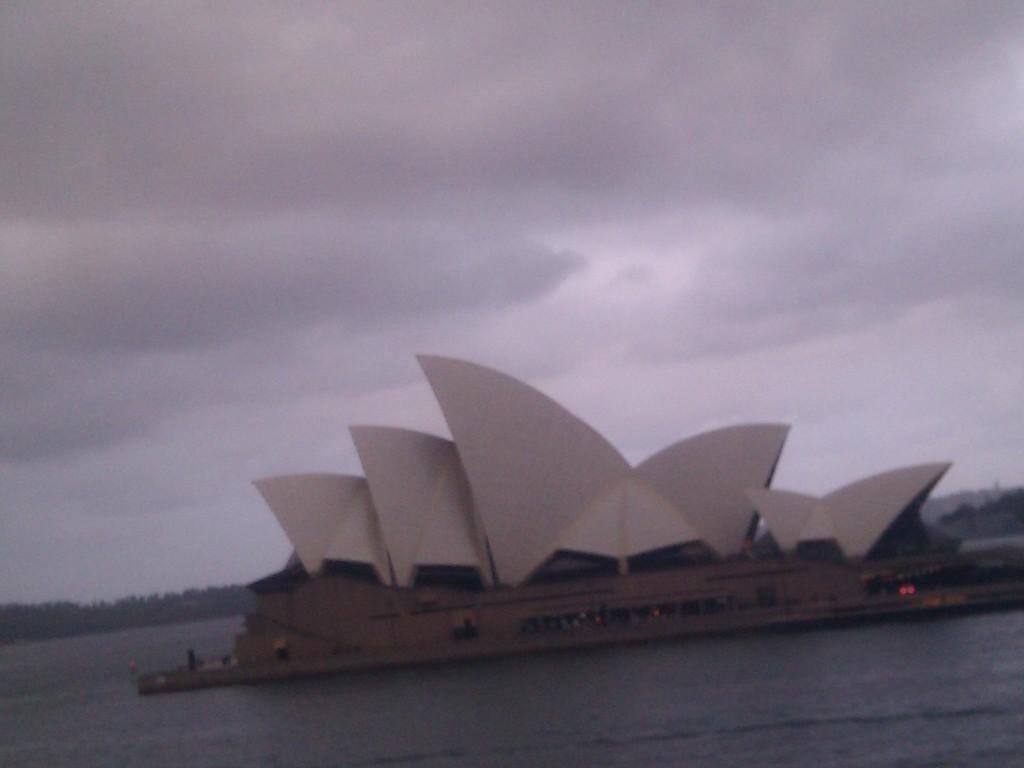In one or two sentences, can you explain what this image depicts? In this image, we can see Sydney opera house. At the bottom, we can see the sea. Background there are few trees, and cloudy sky. 